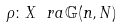<formula> <loc_0><loc_0><loc_500><loc_500>\rho \colon X \ r a \mathbb { G } ( n , N )</formula> 